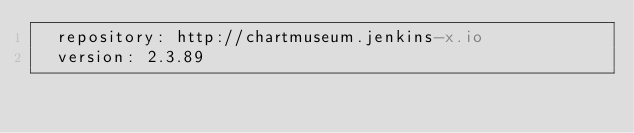<code> <loc_0><loc_0><loc_500><loc_500><_YAML_>  repository: http://chartmuseum.jenkins-x.io
  version: 2.3.89
</code> 